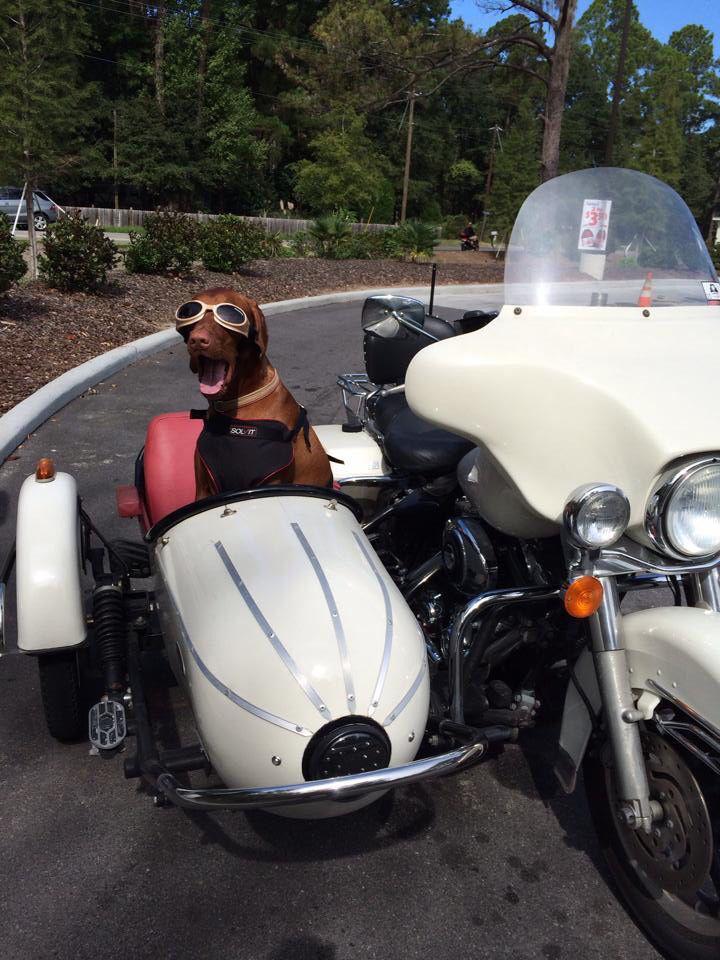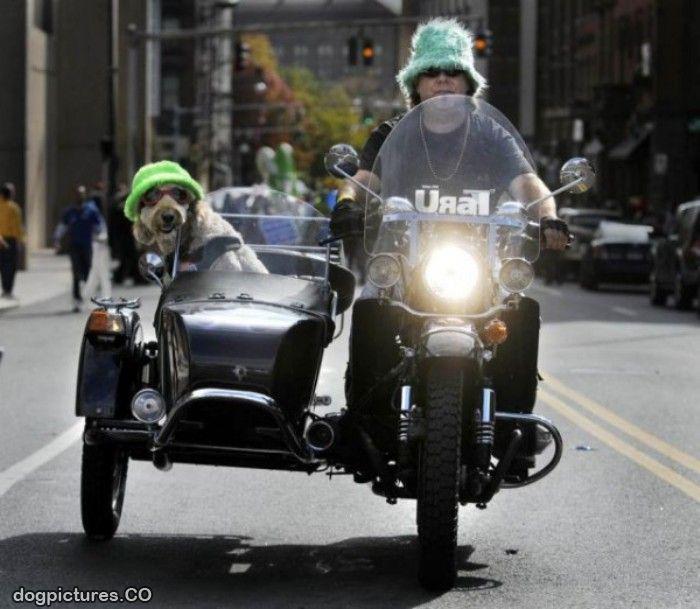The first image is the image on the left, the second image is the image on the right. Assess this claim about the two images: "The left image shows a red dog sitting in a white side car of a motorcycle without a driver on the seat.". Correct or not? Answer yes or no. Yes. 